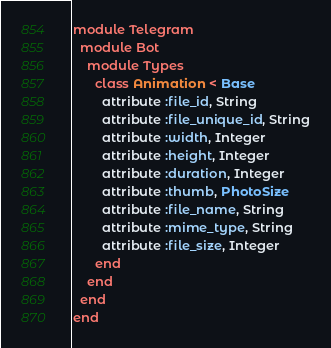<code> <loc_0><loc_0><loc_500><loc_500><_Ruby_>module Telegram
  module Bot
    module Types
      class Animation < Base
        attribute :file_id, String
        attribute :file_unique_id, String
        attribute :width, Integer
        attribute :height, Integer
        attribute :duration, Integer
        attribute :thumb, PhotoSize
        attribute :file_name, String
        attribute :mime_type, String
        attribute :file_size, Integer
      end
    end
  end
end
</code> 